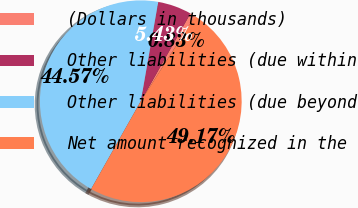Convert chart to OTSL. <chart><loc_0><loc_0><loc_500><loc_500><pie_chart><fcel>(Dollars in thousands)<fcel>Other liabilities (due within<fcel>Other liabilities (due beyond<fcel>Net amount recognized in the<nl><fcel>0.83%<fcel>5.43%<fcel>44.57%<fcel>49.17%<nl></chart> 